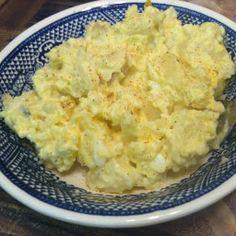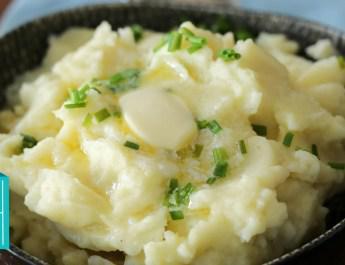The first image is the image on the left, the second image is the image on the right. Considering the images on both sides, is "There are green flakes garnishing only one of the dishes." valid? Answer yes or no. Yes. 